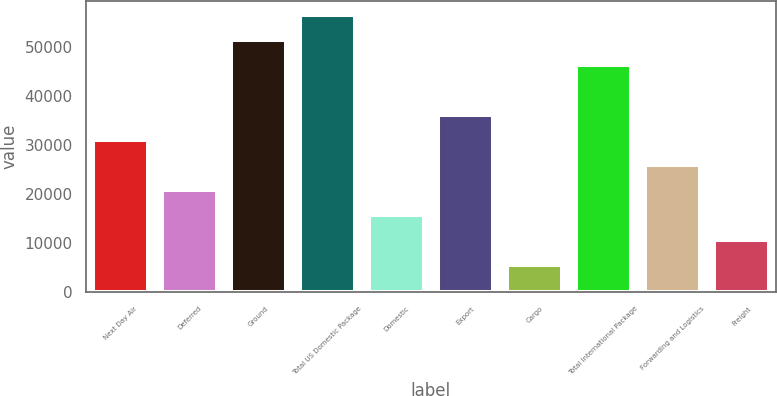<chart> <loc_0><loc_0><loc_500><loc_500><bar_chart><fcel>Next Day Air<fcel>Deferred<fcel>Ground<fcel>Total US Domestic Package<fcel>Domestic<fcel>Export<fcel>Cargo<fcel>Total International Package<fcel>Forwarding and Logistics<fcel>Freight<nl><fcel>31064<fcel>20853<fcel>51486<fcel>56591.5<fcel>15747.5<fcel>36169.5<fcel>5536.5<fcel>46380.5<fcel>25958.5<fcel>10642<nl></chart> 